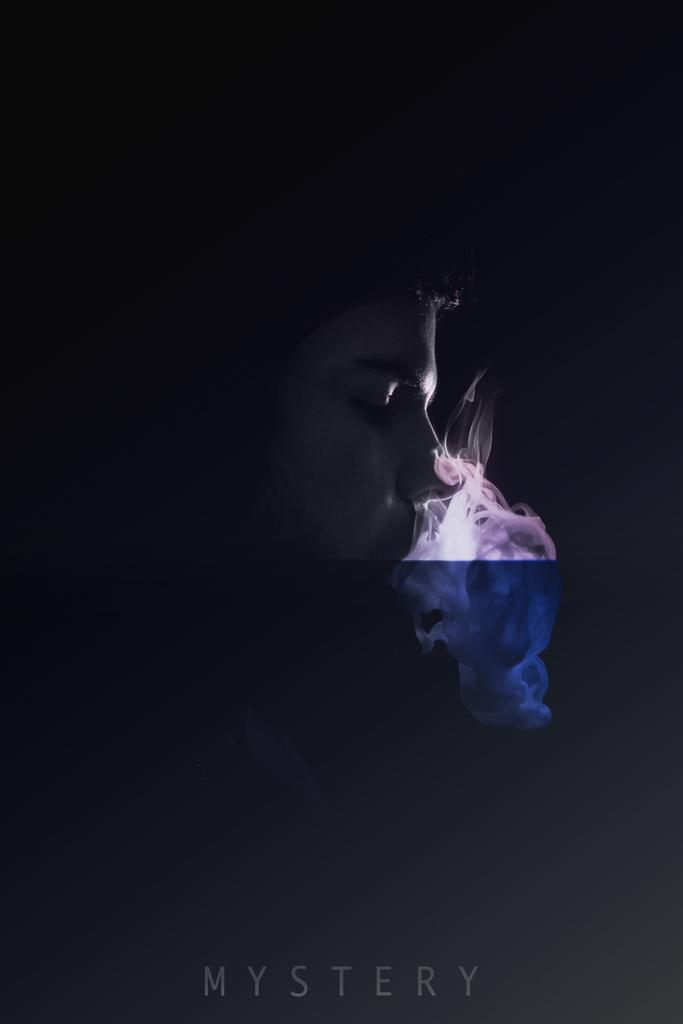Who or what is the main subject in the center of the image? There is a person in the center of the image. What else can be seen in the image besides the person? There is smoke in the image. What type of visual medium is the image? The image appears to be a poster. What word is written on the poster? The poster has the word "mystery" written on it. What type of fowl is depicted in the image? There is no fowl present in the image; it features a person and smoke on a poster with the word "mystery." 